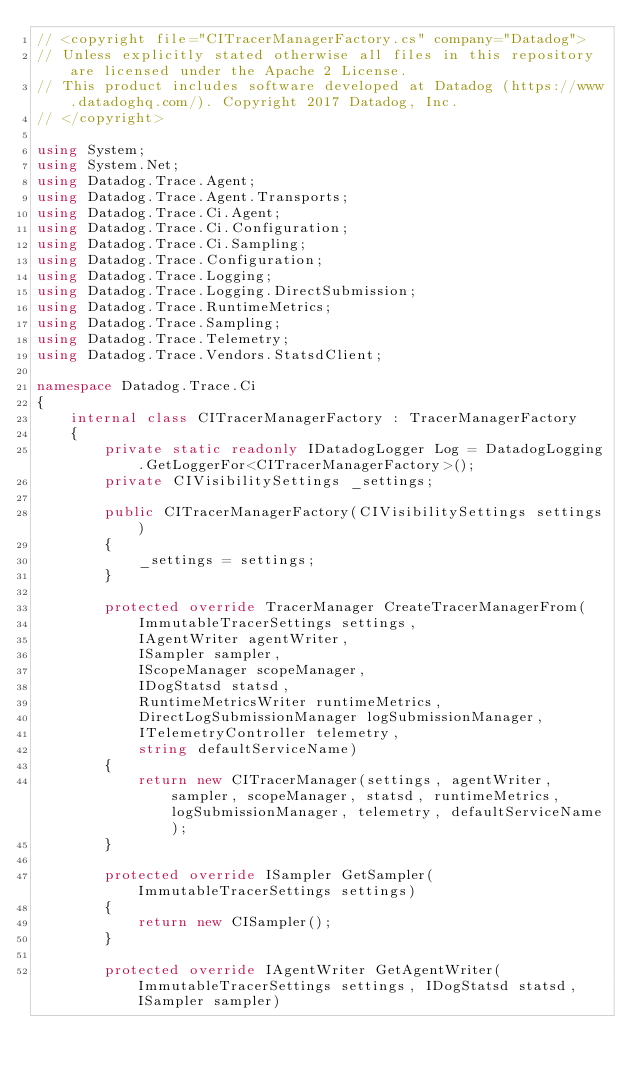Convert code to text. <code><loc_0><loc_0><loc_500><loc_500><_C#_>// <copyright file="CITracerManagerFactory.cs" company="Datadog">
// Unless explicitly stated otherwise all files in this repository are licensed under the Apache 2 License.
// This product includes software developed at Datadog (https://www.datadoghq.com/). Copyright 2017 Datadog, Inc.
// </copyright>

using System;
using System.Net;
using Datadog.Trace.Agent;
using Datadog.Trace.Agent.Transports;
using Datadog.Trace.Ci.Agent;
using Datadog.Trace.Ci.Configuration;
using Datadog.Trace.Ci.Sampling;
using Datadog.Trace.Configuration;
using Datadog.Trace.Logging;
using Datadog.Trace.Logging.DirectSubmission;
using Datadog.Trace.RuntimeMetrics;
using Datadog.Trace.Sampling;
using Datadog.Trace.Telemetry;
using Datadog.Trace.Vendors.StatsdClient;

namespace Datadog.Trace.Ci
{
    internal class CITracerManagerFactory : TracerManagerFactory
    {
        private static readonly IDatadogLogger Log = DatadogLogging.GetLoggerFor<CITracerManagerFactory>();
        private CIVisibilitySettings _settings;

        public CITracerManagerFactory(CIVisibilitySettings settings)
        {
            _settings = settings;
        }

        protected override TracerManager CreateTracerManagerFrom(
            ImmutableTracerSettings settings,
            IAgentWriter agentWriter,
            ISampler sampler,
            IScopeManager scopeManager,
            IDogStatsd statsd,
            RuntimeMetricsWriter runtimeMetrics,
            DirectLogSubmissionManager logSubmissionManager,
            ITelemetryController telemetry,
            string defaultServiceName)
        {
            return new CITracerManager(settings, agentWriter, sampler, scopeManager, statsd, runtimeMetrics, logSubmissionManager, telemetry, defaultServiceName);
        }

        protected override ISampler GetSampler(ImmutableTracerSettings settings)
        {
            return new CISampler();
        }

        protected override IAgentWriter GetAgentWriter(ImmutableTracerSettings settings, IDogStatsd statsd, ISampler sampler)</code> 